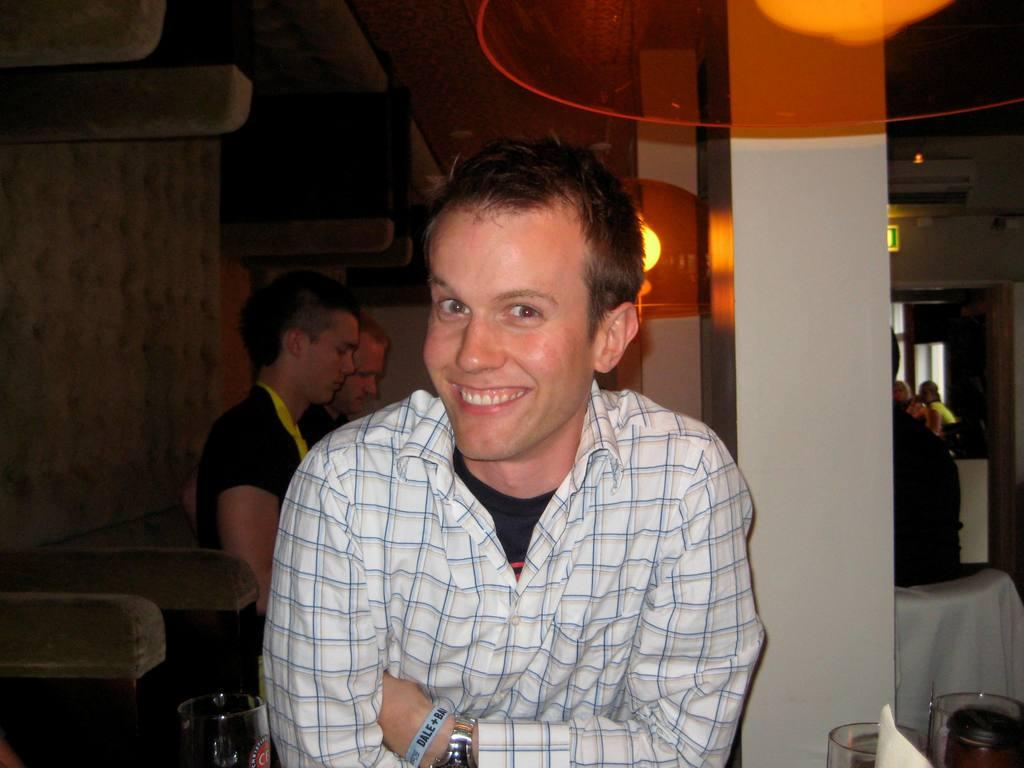Who is the main subject in the image? There is a man in the center of the image. What is the man doing in the image? The man is smiling. What can be seen in the background of the image? There are persons, chairs, and a wall in the background of the image. What objects are in the front of the image? There are glasses in the front of the image. What type of mark can be seen on the wall in the image? There is no mark visible on the wall in the image. How many eggs are present on the table in the image? There are no eggs present in the image. 